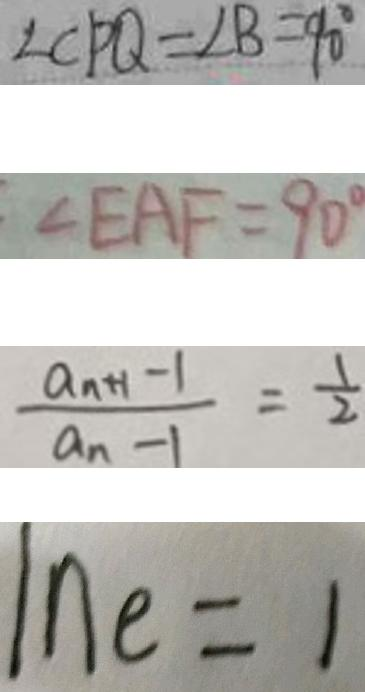<formula> <loc_0><loc_0><loc_500><loc_500>\angle C P Q = \angle B = 9 0 ^ { \circ } 
 \angle E A F = 9 0 ^ { \circ } 
 \frac { a _ { n + 1 } - 1 } { a _ { n - 1 } } = \frac { 1 } { 2 } 
 \ln e = 1</formula> 